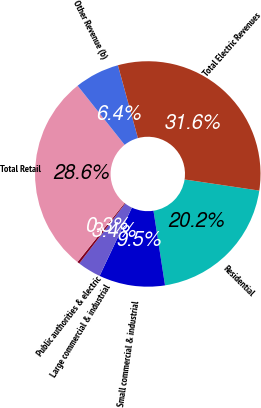Convert chart. <chart><loc_0><loc_0><loc_500><loc_500><pie_chart><fcel>Residential<fcel>Small commercial & industrial<fcel>Large commercial & industrial<fcel>Public authorities & electric<fcel>Total Retail<fcel>Other Revenue (b)<fcel>Total Electric Revenues<nl><fcel>20.2%<fcel>9.47%<fcel>3.37%<fcel>0.33%<fcel>28.58%<fcel>6.42%<fcel>31.63%<nl></chart> 